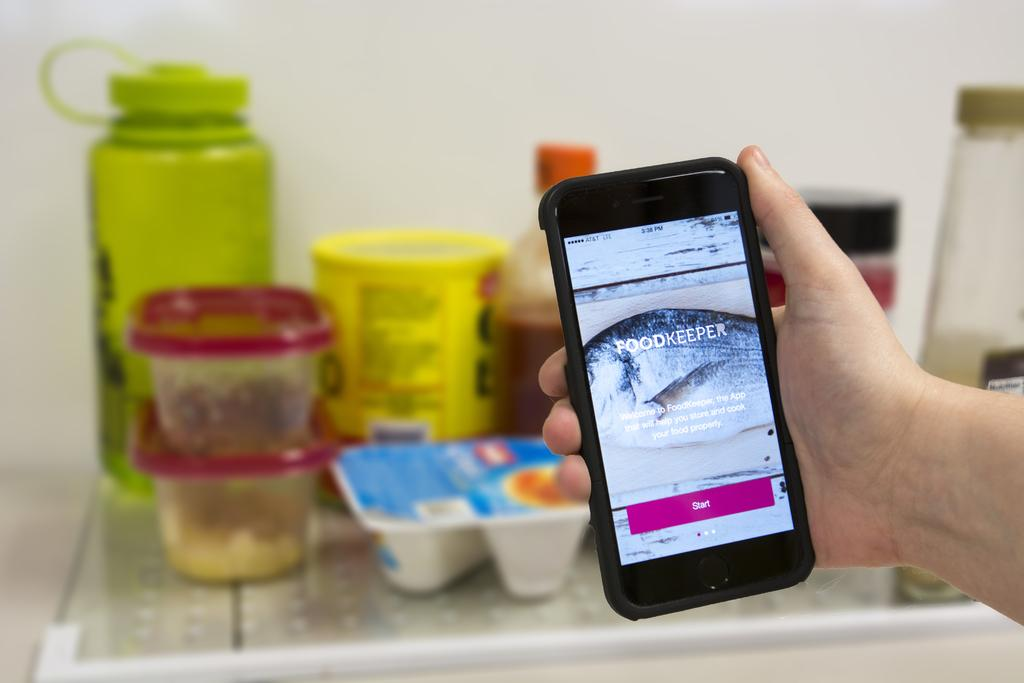What is the person holding in the image? The hand of a person is holding a phone in the image. What can be seen in the background of the image? There are bottles and boxes in the background of the image. What type of ornament is hanging from the phone in the image? There is no ornament hanging from the phone in the image; it is just the hand holding the phone. 